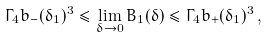<formula> <loc_0><loc_0><loc_500><loc_500>\Gamma _ { 4 } b _ { - } ( \delta _ { 1 } ) ^ { 3 } \leq \lim _ { \delta \to 0 } B _ { 1 } ( \delta ) \leq \Gamma _ { 4 } b _ { + } ( \delta _ { 1 } ) ^ { 3 } \, ,</formula> 